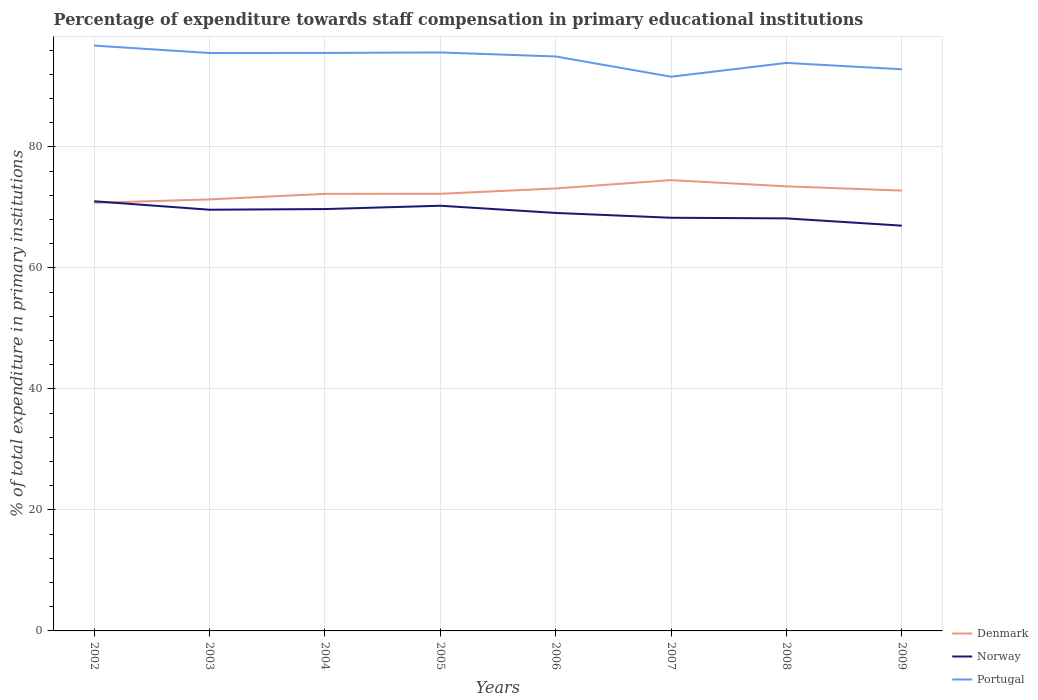How many different coloured lines are there?
Your response must be concise. 3. Does the line corresponding to Denmark intersect with the line corresponding to Norway?
Keep it short and to the point. Yes. Is the number of lines equal to the number of legend labels?
Your answer should be compact. Yes. Across all years, what is the maximum percentage of expenditure towards staff compensation in Norway?
Keep it short and to the point. 66.97. In which year was the percentage of expenditure towards staff compensation in Norway maximum?
Your answer should be very brief. 2009. What is the total percentage of expenditure towards staff compensation in Denmark in the graph?
Offer a terse response. -0.93. What is the difference between the highest and the second highest percentage of expenditure towards staff compensation in Denmark?
Give a very brief answer. 3.75. What is the difference between the highest and the lowest percentage of expenditure towards staff compensation in Portugal?
Your response must be concise. 5. How many years are there in the graph?
Offer a very short reply. 8. What is the difference between two consecutive major ticks on the Y-axis?
Your answer should be compact. 20. Does the graph contain grids?
Your answer should be compact. Yes. Where does the legend appear in the graph?
Provide a succinct answer. Bottom right. How many legend labels are there?
Offer a very short reply. 3. How are the legend labels stacked?
Offer a terse response. Vertical. What is the title of the graph?
Your answer should be compact. Percentage of expenditure towards staff compensation in primary educational institutions. Does "El Salvador" appear as one of the legend labels in the graph?
Offer a terse response. No. What is the label or title of the X-axis?
Your answer should be compact. Years. What is the label or title of the Y-axis?
Make the answer very short. % of total expenditure in primary institutions. What is the % of total expenditure in primary institutions of Denmark in 2002?
Ensure brevity in your answer.  70.75. What is the % of total expenditure in primary institutions of Norway in 2002?
Make the answer very short. 71.01. What is the % of total expenditure in primary institutions in Portugal in 2002?
Your response must be concise. 96.73. What is the % of total expenditure in primary institutions in Denmark in 2003?
Your answer should be compact. 71.31. What is the % of total expenditure in primary institutions of Norway in 2003?
Your response must be concise. 69.61. What is the % of total expenditure in primary institutions of Portugal in 2003?
Keep it short and to the point. 95.51. What is the % of total expenditure in primary institutions of Denmark in 2004?
Give a very brief answer. 72.23. What is the % of total expenditure in primary institutions in Norway in 2004?
Make the answer very short. 69.71. What is the % of total expenditure in primary institutions in Portugal in 2004?
Offer a terse response. 95.52. What is the % of total expenditure in primary institutions in Denmark in 2005?
Make the answer very short. 72.24. What is the % of total expenditure in primary institutions of Norway in 2005?
Provide a short and direct response. 70.27. What is the % of total expenditure in primary institutions in Portugal in 2005?
Make the answer very short. 95.6. What is the % of total expenditure in primary institutions in Denmark in 2006?
Ensure brevity in your answer.  73.12. What is the % of total expenditure in primary institutions in Norway in 2006?
Keep it short and to the point. 69.07. What is the % of total expenditure in primary institutions of Portugal in 2006?
Your answer should be compact. 94.93. What is the % of total expenditure in primary institutions in Denmark in 2007?
Give a very brief answer. 74.5. What is the % of total expenditure in primary institutions of Norway in 2007?
Make the answer very short. 68.28. What is the % of total expenditure in primary institutions of Portugal in 2007?
Your answer should be very brief. 91.59. What is the % of total expenditure in primary institutions in Denmark in 2008?
Your answer should be very brief. 73.47. What is the % of total expenditure in primary institutions of Norway in 2008?
Ensure brevity in your answer.  68.17. What is the % of total expenditure in primary institutions in Portugal in 2008?
Your answer should be compact. 93.87. What is the % of total expenditure in primary institutions of Denmark in 2009?
Your answer should be very brief. 72.77. What is the % of total expenditure in primary institutions of Norway in 2009?
Your response must be concise. 66.97. What is the % of total expenditure in primary institutions in Portugal in 2009?
Your response must be concise. 92.82. Across all years, what is the maximum % of total expenditure in primary institutions of Denmark?
Your answer should be very brief. 74.5. Across all years, what is the maximum % of total expenditure in primary institutions in Norway?
Your answer should be very brief. 71.01. Across all years, what is the maximum % of total expenditure in primary institutions in Portugal?
Make the answer very short. 96.73. Across all years, what is the minimum % of total expenditure in primary institutions of Denmark?
Your answer should be very brief. 70.75. Across all years, what is the minimum % of total expenditure in primary institutions in Norway?
Make the answer very short. 66.97. Across all years, what is the minimum % of total expenditure in primary institutions in Portugal?
Keep it short and to the point. 91.59. What is the total % of total expenditure in primary institutions of Denmark in the graph?
Ensure brevity in your answer.  580.38. What is the total % of total expenditure in primary institutions of Norway in the graph?
Your answer should be compact. 553.09. What is the total % of total expenditure in primary institutions of Portugal in the graph?
Ensure brevity in your answer.  756.56. What is the difference between the % of total expenditure in primary institutions of Denmark in 2002 and that in 2003?
Your response must be concise. -0.56. What is the difference between the % of total expenditure in primary institutions of Norway in 2002 and that in 2003?
Offer a very short reply. 1.4. What is the difference between the % of total expenditure in primary institutions in Portugal in 2002 and that in 2003?
Give a very brief answer. 1.23. What is the difference between the % of total expenditure in primary institutions of Denmark in 2002 and that in 2004?
Provide a succinct answer. -1.48. What is the difference between the % of total expenditure in primary institutions in Norway in 2002 and that in 2004?
Make the answer very short. 1.29. What is the difference between the % of total expenditure in primary institutions in Portugal in 2002 and that in 2004?
Offer a terse response. 1.21. What is the difference between the % of total expenditure in primary institutions of Denmark in 2002 and that in 2005?
Offer a terse response. -1.49. What is the difference between the % of total expenditure in primary institutions in Norway in 2002 and that in 2005?
Make the answer very short. 0.74. What is the difference between the % of total expenditure in primary institutions of Portugal in 2002 and that in 2005?
Your answer should be compact. 1.14. What is the difference between the % of total expenditure in primary institutions of Denmark in 2002 and that in 2006?
Your answer should be compact. -2.38. What is the difference between the % of total expenditure in primary institutions of Norway in 2002 and that in 2006?
Offer a terse response. 1.93. What is the difference between the % of total expenditure in primary institutions of Portugal in 2002 and that in 2006?
Give a very brief answer. 1.8. What is the difference between the % of total expenditure in primary institutions of Denmark in 2002 and that in 2007?
Provide a short and direct response. -3.75. What is the difference between the % of total expenditure in primary institutions in Norway in 2002 and that in 2007?
Make the answer very short. 2.73. What is the difference between the % of total expenditure in primary institutions in Portugal in 2002 and that in 2007?
Give a very brief answer. 5.14. What is the difference between the % of total expenditure in primary institutions in Denmark in 2002 and that in 2008?
Ensure brevity in your answer.  -2.72. What is the difference between the % of total expenditure in primary institutions of Norway in 2002 and that in 2008?
Give a very brief answer. 2.83. What is the difference between the % of total expenditure in primary institutions of Portugal in 2002 and that in 2008?
Your response must be concise. 2.86. What is the difference between the % of total expenditure in primary institutions in Denmark in 2002 and that in 2009?
Your response must be concise. -2.02. What is the difference between the % of total expenditure in primary institutions of Norway in 2002 and that in 2009?
Ensure brevity in your answer.  4.03. What is the difference between the % of total expenditure in primary institutions of Portugal in 2002 and that in 2009?
Ensure brevity in your answer.  3.92. What is the difference between the % of total expenditure in primary institutions in Denmark in 2003 and that in 2004?
Your answer should be compact. -0.92. What is the difference between the % of total expenditure in primary institutions of Norway in 2003 and that in 2004?
Keep it short and to the point. -0.11. What is the difference between the % of total expenditure in primary institutions in Portugal in 2003 and that in 2004?
Your answer should be compact. -0.01. What is the difference between the % of total expenditure in primary institutions of Denmark in 2003 and that in 2005?
Your response must be concise. -0.93. What is the difference between the % of total expenditure in primary institutions in Norway in 2003 and that in 2005?
Your response must be concise. -0.66. What is the difference between the % of total expenditure in primary institutions of Portugal in 2003 and that in 2005?
Make the answer very short. -0.09. What is the difference between the % of total expenditure in primary institutions in Denmark in 2003 and that in 2006?
Offer a very short reply. -1.81. What is the difference between the % of total expenditure in primary institutions of Norway in 2003 and that in 2006?
Ensure brevity in your answer.  0.53. What is the difference between the % of total expenditure in primary institutions of Portugal in 2003 and that in 2006?
Give a very brief answer. 0.57. What is the difference between the % of total expenditure in primary institutions in Denmark in 2003 and that in 2007?
Give a very brief answer. -3.19. What is the difference between the % of total expenditure in primary institutions of Norway in 2003 and that in 2007?
Your answer should be very brief. 1.33. What is the difference between the % of total expenditure in primary institutions of Portugal in 2003 and that in 2007?
Your answer should be compact. 3.92. What is the difference between the % of total expenditure in primary institutions in Denmark in 2003 and that in 2008?
Offer a very short reply. -2.16. What is the difference between the % of total expenditure in primary institutions in Norway in 2003 and that in 2008?
Your answer should be compact. 1.43. What is the difference between the % of total expenditure in primary institutions of Portugal in 2003 and that in 2008?
Your answer should be compact. 1.64. What is the difference between the % of total expenditure in primary institutions of Denmark in 2003 and that in 2009?
Offer a terse response. -1.46. What is the difference between the % of total expenditure in primary institutions in Norway in 2003 and that in 2009?
Offer a terse response. 2.63. What is the difference between the % of total expenditure in primary institutions in Portugal in 2003 and that in 2009?
Offer a very short reply. 2.69. What is the difference between the % of total expenditure in primary institutions of Denmark in 2004 and that in 2005?
Give a very brief answer. -0.01. What is the difference between the % of total expenditure in primary institutions of Norway in 2004 and that in 2005?
Give a very brief answer. -0.55. What is the difference between the % of total expenditure in primary institutions in Portugal in 2004 and that in 2005?
Offer a very short reply. -0.08. What is the difference between the % of total expenditure in primary institutions in Denmark in 2004 and that in 2006?
Ensure brevity in your answer.  -0.89. What is the difference between the % of total expenditure in primary institutions of Norway in 2004 and that in 2006?
Give a very brief answer. 0.64. What is the difference between the % of total expenditure in primary institutions in Portugal in 2004 and that in 2006?
Your answer should be compact. 0.58. What is the difference between the % of total expenditure in primary institutions in Denmark in 2004 and that in 2007?
Ensure brevity in your answer.  -2.27. What is the difference between the % of total expenditure in primary institutions in Norway in 2004 and that in 2007?
Provide a short and direct response. 1.44. What is the difference between the % of total expenditure in primary institutions of Portugal in 2004 and that in 2007?
Ensure brevity in your answer.  3.93. What is the difference between the % of total expenditure in primary institutions in Denmark in 2004 and that in 2008?
Offer a very short reply. -1.24. What is the difference between the % of total expenditure in primary institutions of Norway in 2004 and that in 2008?
Your response must be concise. 1.54. What is the difference between the % of total expenditure in primary institutions in Portugal in 2004 and that in 2008?
Your answer should be very brief. 1.65. What is the difference between the % of total expenditure in primary institutions of Denmark in 2004 and that in 2009?
Provide a short and direct response. -0.54. What is the difference between the % of total expenditure in primary institutions in Norway in 2004 and that in 2009?
Offer a terse response. 2.74. What is the difference between the % of total expenditure in primary institutions in Portugal in 2004 and that in 2009?
Give a very brief answer. 2.7. What is the difference between the % of total expenditure in primary institutions in Denmark in 2005 and that in 2006?
Provide a short and direct response. -0.88. What is the difference between the % of total expenditure in primary institutions of Norway in 2005 and that in 2006?
Keep it short and to the point. 1.19. What is the difference between the % of total expenditure in primary institutions in Portugal in 2005 and that in 2006?
Offer a very short reply. 0.66. What is the difference between the % of total expenditure in primary institutions in Denmark in 2005 and that in 2007?
Your answer should be very brief. -2.26. What is the difference between the % of total expenditure in primary institutions of Norway in 2005 and that in 2007?
Keep it short and to the point. 1.99. What is the difference between the % of total expenditure in primary institutions in Portugal in 2005 and that in 2007?
Offer a very short reply. 4.01. What is the difference between the % of total expenditure in primary institutions of Denmark in 2005 and that in 2008?
Provide a succinct answer. -1.23. What is the difference between the % of total expenditure in primary institutions of Norway in 2005 and that in 2008?
Keep it short and to the point. 2.09. What is the difference between the % of total expenditure in primary institutions of Portugal in 2005 and that in 2008?
Provide a succinct answer. 1.73. What is the difference between the % of total expenditure in primary institutions of Denmark in 2005 and that in 2009?
Offer a terse response. -0.53. What is the difference between the % of total expenditure in primary institutions of Norway in 2005 and that in 2009?
Make the answer very short. 3.29. What is the difference between the % of total expenditure in primary institutions in Portugal in 2005 and that in 2009?
Offer a terse response. 2.78. What is the difference between the % of total expenditure in primary institutions of Denmark in 2006 and that in 2007?
Keep it short and to the point. -1.37. What is the difference between the % of total expenditure in primary institutions in Norway in 2006 and that in 2007?
Give a very brief answer. 0.8. What is the difference between the % of total expenditure in primary institutions in Portugal in 2006 and that in 2007?
Ensure brevity in your answer.  3.35. What is the difference between the % of total expenditure in primary institutions in Denmark in 2006 and that in 2008?
Your answer should be very brief. -0.35. What is the difference between the % of total expenditure in primary institutions of Norway in 2006 and that in 2008?
Make the answer very short. 0.9. What is the difference between the % of total expenditure in primary institutions of Portugal in 2006 and that in 2008?
Make the answer very short. 1.06. What is the difference between the % of total expenditure in primary institutions of Denmark in 2006 and that in 2009?
Keep it short and to the point. 0.36. What is the difference between the % of total expenditure in primary institutions in Norway in 2006 and that in 2009?
Provide a succinct answer. 2.1. What is the difference between the % of total expenditure in primary institutions of Portugal in 2006 and that in 2009?
Your response must be concise. 2.12. What is the difference between the % of total expenditure in primary institutions in Denmark in 2007 and that in 2008?
Your answer should be compact. 1.03. What is the difference between the % of total expenditure in primary institutions in Norway in 2007 and that in 2008?
Make the answer very short. 0.11. What is the difference between the % of total expenditure in primary institutions in Portugal in 2007 and that in 2008?
Your response must be concise. -2.28. What is the difference between the % of total expenditure in primary institutions in Denmark in 2007 and that in 2009?
Your response must be concise. 1.73. What is the difference between the % of total expenditure in primary institutions in Norway in 2007 and that in 2009?
Offer a terse response. 1.3. What is the difference between the % of total expenditure in primary institutions of Portugal in 2007 and that in 2009?
Offer a terse response. -1.23. What is the difference between the % of total expenditure in primary institutions of Denmark in 2008 and that in 2009?
Ensure brevity in your answer.  0.7. What is the difference between the % of total expenditure in primary institutions in Portugal in 2008 and that in 2009?
Offer a terse response. 1.05. What is the difference between the % of total expenditure in primary institutions in Denmark in 2002 and the % of total expenditure in primary institutions in Norway in 2003?
Offer a very short reply. 1.14. What is the difference between the % of total expenditure in primary institutions of Denmark in 2002 and the % of total expenditure in primary institutions of Portugal in 2003?
Provide a succinct answer. -24.76. What is the difference between the % of total expenditure in primary institutions in Norway in 2002 and the % of total expenditure in primary institutions in Portugal in 2003?
Provide a short and direct response. -24.5. What is the difference between the % of total expenditure in primary institutions of Denmark in 2002 and the % of total expenditure in primary institutions of Norway in 2004?
Your answer should be very brief. 1.03. What is the difference between the % of total expenditure in primary institutions of Denmark in 2002 and the % of total expenditure in primary institutions of Portugal in 2004?
Your answer should be very brief. -24.77. What is the difference between the % of total expenditure in primary institutions in Norway in 2002 and the % of total expenditure in primary institutions in Portugal in 2004?
Your answer should be very brief. -24.51. What is the difference between the % of total expenditure in primary institutions in Denmark in 2002 and the % of total expenditure in primary institutions in Norway in 2005?
Keep it short and to the point. 0.48. What is the difference between the % of total expenditure in primary institutions of Denmark in 2002 and the % of total expenditure in primary institutions of Portugal in 2005?
Your response must be concise. -24.85. What is the difference between the % of total expenditure in primary institutions of Norway in 2002 and the % of total expenditure in primary institutions of Portugal in 2005?
Provide a short and direct response. -24.59. What is the difference between the % of total expenditure in primary institutions of Denmark in 2002 and the % of total expenditure in primary institutions of Norway in 2006?
Give a very brief answer. 1.67. What is the difference between the % of total expenditure in primary institutions of Denmark in 2002 and the % of total expenditure in primary institutions of Portugal in 2006?
Your response must be concise. -24.19. What is the difference between the % of total expenditure in primary institutions in Norway in 2002 and the % of total expenditure in primary institutions in Portugal in 2006?
Your response must be concise. -23.93. What is the difference between the % of total expenditure in primary institutions in Denmark in 2002 and the % of total expenditure in primary institutions in Norway in 2007?
Provide a succinct answer. 2.47. What is the difference between the % of total expenditure in primary institutions in Denmark in 2002 and the % of total expenditure in primary institutions in Portugal in 2007?
Make the answer very short. -20.84. What is the difference between the % of total expenditure in primary institutions in Norway in 2002 and the % of total expenditure in primary institutions in Portugal in 2007?
Offer a terse response. -20.58. What is the difference between the % of total expenditure in primary institutions in Denmark in 2002 and the % of total expenditure in primary institutions in Norway in 2008?
Offer a terse response. 2.57. What is the difference between the % of total expenditure in primary institutions of Denmark in 2002 and the % of total expenditure in primary institutions of Portugal in 2008?
Ensure brevity in your answer.  -23.12. What is the difference between the % of total expenditure in primary institutions of Norway in 2002 and the % of total expenditure in primary institutions of Portugal in 2008?
Your answer should be very brief. -22.86. What is the difference between the % of total expenditure in primary institutions in Denmark in 2002 and the % of total expenditure in primary institutions in Norway in 2009?
Give a very brief answer. 3.77. What is the difference between the % of total expenditure in primary institutions in Denmark in 2002 and the % of total expenditure in primary institutions in Portugal in 2009?
Offer a terse response. -22.07. What is the difference between the % of total expenditure in primary institutions in Norway in 2002 and the % of total expenditure in primary institutions in Portugal in 2009?
Make the answer very short. -21.81. What is the difference between the % of total expenditure in primary institutions of Denmark in 2003 and the % of total expenditure in primary institutions of Norway in 2004?
Give a very brief answer. 1.6. What is the difference between the % of total expenditure in primary institutions in Denmark in 2003 and the % of total expenditure in primary institutions in Portugal in 2004?
Make the answer very short. -24.21. What is the difference between the % of total expenditure in primary institutions in Norway in 2003 and the % of total expenditure in primary institutions in Portugal in 2004?
Your answer should be compact. -25.91. What is the difference between the % of total expenditure in primary institutions in Denmark in 2003 and the % of total expenditure in primary institutions in Norway in 2005?
Offer a terse response. 1.04. What is the difference between the % of total expenditure in primary institutions in Denmark in 2003 and the % of total expenditure in primary institutions in Portugal in 2005?
Provide a short and direct response. -24.29. What is the difference between the % of total expenditure in primary institutions of Norway in 2003 and the % of total expenditure in primary institutions of Portugal in 2005?
Your response must be concise. -25.99. What is the difference between the % of total expenditure in primary institutions in Denmark in 2003 and the % of total expenditure in primary institutions in Norway in 2006?
Give a very brief answer. 2.24. What is the difference between the % of total expenditure in primary institutions in Denmark in 2003 and the % of total expenditure in primary institutions in Portugal in 2006?
Your response must be concise. -23.62. What is the difference between the % of total expenditure in primary institutions of Norway in 2003 and the % of total expenditure in primary institutions of Portugal in 2006?
Your answer should be compact. -25.33. What is the difference between the % of total expenditure in primary institutions of Denmark in 2003 and the % of total expenditure in primary institutions of Norway in 2007?
Your answer should be very brief. 3.03. What is the difference between the % of total expenditure in primary institutions of Denmark in 2003 and the % of total expenditure in primary institutions of Portugal in 2007?
Your response must be concise. -20.28. What is the difference between the % of total expenditure in primary institutions of Norway in 2003 and the % of total expenditure in primary institutions of Portugal in 2007?
Ensure brevity in your answer.  -21.98. What is the difference between the % of total expenditure in primary institutions of Denmark in 2003 and the % of total expenditure in primary institutions of Norway in 2008?
Give a very brief answer. 3.14. What is the difference between the % of total expenditure in primary institutions in Denmark in 2003 and the % of total expenditure in primary institutions in Portugal in 2008?
Make the answer very short. -22.56. What is the difference between the % of total expenditure in primary institutions of Norway in 2003 and the % of total expenditure in primary institutions of Portugal in 2008?
Keep it short and to the point. -24.26. What is the difference between the % of total expenditure in primary institutions of Denmark in 2003 and the % of total expenditure in primary institutions of Norway in 2009?
Provide a succinct answer. 4.34. What is the difference between the % of total expenditure in primary institutions of Denmark in 2003 and the % of total expenditure in primary institutions of Portugal in 2009?
Keep it short and to the point. -21.51. What is the difference between the % of total expenditure in primary institutions of Norway in 2003 and the % of total expenditure in primary institutions of Portugal in 2009?
Your answer should be very brief. -23.21. What is the difference between the % of total expenditure in primary institutions of Denmark in 2004 and the % of total expenditure in primary institutions of Norway in 2005?
Provide a short and direct response. 1.96. What is the difference between the % of total expenditure in primary institutions of Denmark in 2004 and the % of total expenditure in primary institutions of Portugal in 2005?
Your answer should be very brief. -23.37. What is the difference between the % of total expenditure in primary institutions of Norway in 2004 and the % of total expenditure in primary institutions of Portugal in 2005?
Offer a terse response. -25.88. What is the difference between the % of total expenditure in primary institutions of Denmark in 2004 and the % of total expenditure in primary institutions of Norway in 2006?
Give a very brief answer. 3.15. What is the difference between the % of total expenditure in primary institutions of Denmark in 2004 and the % of total expenditure in primary institutions of Portugal in 2006?
Keep it short and to the point. -22.71. What is the difference between the % of total expenditure in primary institutions of Norway in 2004 and the % of total expenditure in primary institutions of Portugal in 2006?
Offer a very short reply. -25.22. What is the difference between the % of total expenditure in primary institutions in Denmark in 2004 and the % of total expenditure in primary institutions in Norway in 2007?
Your answer should be very brief. 3.95. What is the difference between the % of total expenditure in primary institutions of Denmark in 2004 and the % of total expenditure in primary institutions of Portugal in 2007?
Your answer should be very brief. -19.36. What is the difference between the % of total expenditure in primary institutions in Norway in 2004 and the % of total expenditure in primary institutions in Portugal in 2007?
Give a very brief answer. -21.87. What is the difference between the % of total expenditure in primary institutions in Denmark in 2004 and the % of total expenditure in primary institutions in Norway in 2008?
Your answer should be compact. 4.05. What is the difference between the % of total expenditure in primary institutions in Denmark in 2004 and the % of total expenditure in primary institutions in Portugal in 2008?
Offer a very short reply. -21.64. What is the difference between the % of total expenditure in primary institutions in Norway in 2004 and the % of total expenditure in primary institutions in Portugal in 2008?
Your answer should be very brief. -24.15. What is the difference between the % of total expenditure in primary institutions in Denmark in 2004 and the % of total expenditure in primary institutions in Norway in 2009?
Provide a succinct answer. 5.25. What is the difference between the % of total expenditure in primary institutions of Denmark in 2004 and the % of total expenditure in primary institutions of Portugal in 2009?
Give a very brief answer. -20.59. What is the difference between the % of total expenditure in primary institutions in Norway in 2004 and the % of total expenditure in primary institutions in Portugal in 2009?
Ensure brevity in your answer.  -23.1. What is the difference between the % of total expenditure in primary institutions in Denmark in 2005 and the % of total expenditure in primary institutions in Norway in 2006?
Ensure brevity in your answer.  3.16. What is the difference between the % of total expenditure in primary institutions in Denmark in 2005 and the % of total expenditure in primary institutions in Portugal in 2006?
Provide a short and direct response. -22.69. What is the difference between the % of total expenditure in primary institutions in Norway in 2005 and the % of total expenditure in primary institutions in Portugal in 2006?
Give a very brief answer. -24.67. What is the difference between the % of total expenditure in primary institutions in Denmark in 2005 and the % of total expenditure in primary institutions in Norway in 2007?
Your answer should be compact. 3.96. What is the difference between the % of total expenditure in primary institutions of Denmark in 2005 and the % of total expenditure in primary institutions of Portugal in 2007?
Keep it short and to the point. -19.35. What is the difference between the % of total expenditure in primary institutions in Norway in 2005 and the % of total expenditure in primary institutions in Portugal in 2007?
Ensure brevity in your answer.  -21.32. What is the difference between the % of total expenditure in primary institutions in Denmark in 2005 and the % of total expenditure in primary institutions in Norway in 2008?
Provide a succinct answer. 4.06. What is the difference between the % of total expenditure in primary institutions of Denmark in 2005 and the % of total expenditure in primary institutions of Portugal in 2008?
Your answer should be compact. -21.63. What is the difference between the % of total expenditure in primary institutions in Norway in 2005 and the % of total expenditure in primary institutions in Portugal in 2008?
Keep it short and to the point. -23.6. What is the difference between the % of total expenditure in primary institutions in Denmark in 2005 and the % of total expenditure in primary institutions in Norway in 2009?
Keep it short and to the point. 5.26. What is the difference between the % of total expenditure in primary institutions in Denmark in 2005 and the % of total expenditure in primary institutions in Portugal in 2009?
Offer a terse response. -20.58. What is the difference between the % of total expenditure in primary institutions in Norway in 2005 and the % of total expenditure in primary institutions in Portugal in 2009?
Give a very brief answer. -22.55. What is the difference between the % of total expenditure in primary institutions in Denmark in 2006 and the % of total expenditure in primary institutions in Norway in 2007?
Provide a succinct answer. 4.84. What is the difference between the % of total expenditure in primary institutions of Denmark in 2006 and the % of total expenditure in primary institutions of Portugal in 2007?
Provide a short and direct response. -18.46. What is the difference between the % of total expenditure in primary institutions in Norway in 2006 and the % of total expenditure in primary institutions in Portugal in 2007?
Give a very brief answer. -22.51. What is the difference between the % of total expenditure in primary institutions in Denmark in 2006 and the % of total expenditure in primary institutions in Norway in 2008?
Offer a terse response. 4.95. What is the difference between the % of total expenditure in primary institutions in Denmark in 2006 and the % of total expenditure in primary institutions in Portugal in 2008?
Provide a succinct answer. -20.75. What is the difference between the % of total expenditure in primary institutions in Norway in 2006 and the % of total expenditure in primary institutions in Portugal in 2008?
Your response must be concise. -24.79. What is the difference between the % of total expenditure in primary institutions of Denmark in 2006 and the % of total expenditure in primary institutions of Norway in 2009?
Your response must be concise. 6.15. What is the difference between the % of total expenditure in primary institutions in Denmark in 2006 and the % of total expenditure in primary institutions in Portugal in 2009?
Ensure brevity in your answer.  -19.69. What is the difference between the % of total expenditure in primary institutions in Norway in 2006 and the % of total expenditure in primary institutions in Portugal in 2009?
Your answer should be compact. -23.74. What is the difference between the % of total expenditure in primary institutions in Denmark in 2007 and the % of total expenditure in primary institutions in Norway in 2008?
Keep it short and to the point. 6.32. What is the difference between the % of total expenditure in primary institutions of Denmark in 2007 and the % of total expenditure in primary institutions of Portugal in 2008?
Keep it short and to the point. -19.37. What is the difference between the % of total expenditure in primary institutions of Norway in 2007 and the % of total expenditure in primary institutions of Portugal in 2008?
Provide a short and direct response. -25.59. What is the difference between the % of total expenditure in primary institutions of Denmark in 2007 and the % of total expenditure in primary institutions of Norway in 2009?
Provide a short and direct response. 7.52. What is the difference between the % of total expenditure in primary institutions of Denmark in 2007 and the % of total expenditure in primary institutions of Portugal in 2009?
Your answer should be very brief. -18.32. What is the difference between the % of total expenditure in primary institutions of Norway in 2007 and the % of total expenditure in primary institutions of Portugal in 2009?
Keep it short and to the point. -24.54. What is the difference between the % of total expenditure in primary institutions in Denmark in 2008 and the % of total expenditure in primary institutions in Norway in 2009?
Make the answer very short. 6.5. What is the difference between the % of total expenditure in primary institutions of Denmark in 2008 and the % of total expenditure in primary institutions of Portugal in 2009?
Offer a terse response. -19.35. What is the difference between the % of total expenditure in primary institutions of Norway in 2008 and the % of total expenditure in primary institutions of Portugal in 2009?
Offer a very short reply. -24.64. What is the average % of total expenditure in primary institutions of Denmark per year?
Your answer should be very brief. 72.55. What is the average % of total expenditure in primary institutions of Norway per year?
Offer a very short reply. 69.14. What is the average % of total expenditure in primary institutions of Portugal per year?
Your response must be concise. 94.57. In the year 2002, what is the difference between the % of total expenditure in primary institutions in Denmark and % of total expenditure in primary institutions in Norway?
Keep it short and to the point. -0.26. In the year 2002, what is the difference between the % of total expenditure in primary institutions in Denmark and % of total expenditure in primary institutions in Portugal?
Make the answer very short. -25.99. In the year 2002, what is the difference between the % of total expenditure in primary institutions in Norway and % of total expenditure in primary institutions in Portugal?
Make the answer very short. -25.73. In the year 2003, what is the difference between the % of total expenditure in primary institutions of Denmark and % of total expenditure in primary institutions of Norway?
Ensure brevity in your answer.  1.7. In the year 2003, what is the difference between the % of total expenditure in primary institutions of Denmark and % of total expenditure in primary institutions of Portugal?
Your response must be concise. -24.2. In the year 2003, what is the difference between the % of total expenditure in primary institutions of Norway and % of total expenditure in primary institutions of Portugal?
Your response must be concise. -25.9. In the year 2004, what is the difference between the % of total expenditure in primary institutions of Denmark and % of total expenditure in primary institutions of Norway?
Ensure brevity in your answer.  2.51. In the year 2004, what is the difference between the % of total expenditure in primary institutions of Denmark and % of total expenditure in primary institutions of Portugal?
Your response must be concise. -23.29. In the year 2004, what is the difference between the % of total expenditure in primary institutions of Norway and % of total expenditure in primary institutions of Portugal?
Give a very brief answer. -25.8. In the year 2005, what is the difference between the % of total expenditure in primary institutions in Denmark and % of total expenditure in primary institutions in Norway?
Offer a very short reply. 1.97. In the year 2005, what is the difference between the % of total expenditure in primary institutions of Denmark and % of total expenditure in primary institutions of Portugal?
Your answer should be compact. -23.36. In the year 2005, what is the difference between the % of total expenditure in primary institutions of Norway and % of total expenditure in primary institutions of Portugal?
Offer a terse response. -25.33. In the year 2006, what is the difference between the % of total expenditure in primary institutions in Denmark and % of total expenditure in primary institutions in Norway?
Keep it short and to the point. 4.05. In the year 2006, what is the difference between the % of total expenditure in primary institutions of Denmark and % of total expenditure in primary institutions of Portugal?
Provide a succinct answer. -21.81. In the year 2006, what is the difference between the % of total expenditure in primary institutions in Norway and % of total expenditure in primary institutions in Portugal?
Offer a very short reply. -25.86. In the year 2007, what is the difference between the % of total expenditure in primary institutions of Denmark and % of total expenditure in primary institutions of Norway?
Provide a succinct answer. 6.22. In the year 2007, what is the difference between the % of total expenditure in primary institutions of Denmark and % of total expenditure in primary institutions of Portugal?
Ensure brevity in your answer.  -17.09. In the year 2007, what is the difference between the % of total expenditure in primary institutions of Norway and % of total expenditure in primary institutions of Portugal?
Provide a succinct answer. -23.31. In the year 2008, what is the difference between the % of total expenditure in primary institutions in Denmark and % of total expenditure in primary institutions in Norway?
Provide a short and direct response. 5.3. In the year 2008, what is the difference between the % of total expenditure in primary institutions in Denmark and % of total expenditure in primary institutions in Portugal?
Your response must be concise. -20.4. In the year 2008, what is the difference between the % of total expenditure in primary institutions of Norway and % of total expenditure in primary institutions of Portugal?
Your answer should be compact. -25.69. In the year 2009, what is the difference between the % of total expenditure in primary institutions in Denmark and % of total expenditure in primary institutions in Norway?
Ensure brevity in your answer.  5.79. In the year 2009, what is the difference between the % of total expenditure in primary institutions of Denmark and % of total expenditure in primary institutions of Portugal?
Your answer should be very brief. -20.05. In the year 2009, what is the difference between the % of total expenditure in primary institutions in Norway and % of total expenditure in primary institutions in Portugal?
Ensure brevity in your answer.  -25.84. What is the ratio of the % of total expenditure in primary institutions in Denmark in 2002 to that in 2003?
Provide a short and direct response. 0.99. What is the ratio of the % of total expenditure in primary institutions of Norway in 2002 to that in 2003?
Give a very brief answer. 1.02. What is the ratio of the % of total expenditure in primary institutions of Portugal in 2002 to that in 2003?
Provide a succinct answer. 1.01. What is the ratio of the % of total expenditure in primary institutions of Denmark in 2002 to that in 2004?
Your answer should be compact. 0.98. What is the ratio of the % of total expenditure in primary institutions in Norway in 2002 to that in 2004?
Your answer should be very brief. 1.02. What is the ratio of the % of total expenditure in primary institutions of Portugal in 2002 to that in 2004?
Keep it short and to the point. 1.01. What is the ratio of the % of total expenditure in primary institutions of Denmark in 2002 to that in 2005?
Provide a short and direct response. 0.98. What is the ratio of the % of total expenditure in primary institutions of Norway in 2002 to that in 2005?
Offer a terse response. 1.01. What is the ratio of the % of total expenditure in primary institutions of Portugal in 2002 to that in 2005?
Your answer should be compact. 1.01. What is the ratio of the % of total expenditure in primary institutions of Denmark in 2002 to that in 2006?
Make the answer very short. 0.97. What is the ratio of the % of total expenditure in primary institutions in Norway in 2002 to that in 2006?
Provide a short and direct response. 1.03. What is the ratio of the % of total expenditure in primary institutions of Portugal in 2002 to that in 2006?
Ensure brevity in your answer.  1.02. What is the ratio of the % of total expenditure in primary institutions in Denmark in 2002 to that in 2007?
Keep it short and to the point. 0.95. What is the ratio of the % of total expenditure in primary institutions of Norway in 2002 to that in 2007?
Your answer should be compact. 1.04. What is the ratio of the % of total expenditure in primary institutions in Portugal in 2002 to that in 2007?
Provide a succinct answer. 1.06. What is the ratio of the % of total expenditure in primary institutions of Denmark in 2002 to that in 2008?
Offer a terse response. 0.96. What is the ratio of the % of total expenditure in primary institutions of Norway in 2002 to that in 2008?
Provide a short and direct response. 1.04. What is the ratio of the % of total expenditure in primary institutions of Portugal in 2002 to that in 2008?
Ensure brevity in your answer.  1.03. What is the ratio of the % of total expenditure in primary institutions in Denmark in 2002 to that in 2009?
Make the answer very short. 0.97. What is the ratio of the % of total expenditure in primary institutions of Norway in 2002 to that in 2009?
Provide a short and direct response. 1.06. What is the ratio of the % of total expenditure in primary institutions of Portugal in 2002 to that in 2009?
Offer a very short reply. 1.04. What is the ratio of the % of total expenditure in primary institutions in Denmark in 2003 to that in 2004?
Your answer should be compact. 0.99. What is the ratio of the % of total expenditure in primary institutions of Norway in 2003 to that in 2004?
Your answer should be compact. 1. What is the ratio of the % of total expenditure in primary institutions in Portugal in 2003 to that in 2004?
Your answer should be very brief. 1. What is the ratio of the % of total expenditure in primary institutions in Denmark in 2003 to that in 2005?
Offer a very short reply. 0.99. What is the ratio of the % of total expenditure in primary institutions of Norway in 2003 to that in 2005?
Your answer should be very brief. 0.99. What is the ratio of the % of total expenditure in primary institutions of Denmark in 2003 to that in 2006?
Your answer should be very brief. 0.98. What is the ratio of the % of total expenditure in primary institutions in Norway in 2003 to that in 2006?
Provide a short and direct response. 1.01. What is the ratio of the % of total expenditure in primary institutions in Denmark in 2003 to that in 2007?
Your answer should be very brief. 0.96. What is the ratio of the % of total expenditure in primary institutions in Norway in 2003 to that in 2007?
Your answer should be very brief. 1.02. What is the ratio of the % of total expenditure in primary institutions in Portugal in 2003 to that in 2007?
Give a very brief answer. 1.04. What is the ratio of the % of total expenditure in primary institutions in Denmark in 2003 to that in 2008?
Your answer should be very brief. 0.97. What is the ratio of the % of total expenditure in primary institutions in Portugal in 2003 to that in 2008?
Provide a short and direct response. 1.02. What is the ratio of the % of total expenditure in primary institutions of Norway in 2003 to that in 2009?
Your answer should be compact. 1.04. What is the ratio of the % of total expenditure in primary institutions of Portugal in 2003 to that in 2009?
Provide a short and direct response. 1.03. What is the ratio of the % of total expenditure in primary institutions in Norway in 2004 to that in 2005?
Offer a very short reply. 0.99. What is the ratio of the % of total expenditure in primary institutions of Norway in 2004 to that in 2006?
Give a very brief answer. 1.01. What is the ratio of the % of total expenditure in primary institutions of Denmark in 2004 to that in 2007?
Make the answer very short. 0.97. What is the ratio of the % of total expenditure in primary institutions in Portugal in 2004 to that in 2007?
Offer a terse response. 1.04. What is the ratio of the % of total expenditure in primary institutions of Denmark in 2004 to that in 2008?
Give a very brief answer. 0.98. What is the ratio of the % of total expenditure in primary institutions of Norway in 2004 to that in 2008?
Give a very brief answer. 1.02. What is the ratio of the % of total expenditure in primary institutions in Portugal in 2004 to that in 2008?
Ensure brevity in your answer.  1.02. What is the ratio of the % of total expenditure in primary institutions in Denmark in 2004 to that in 2009?
Give a very brief answer. 0.99. What is the ratio of the % of total expenditure in primary institutions in Norway in 2004 to that in 2009?
Your answer should be compact. 1.04. What is the ratio of the % of total expenditure in primary institutions of Portugal in 2004 to that in 2009?
Your answer should be very brief. 1.03. What is the ratio of the % of total expenditure in primary institutions of Denmark in 2005 to that in 2006?
Offer a terse response. 0.99. What is the ratio of the % of total expenditure in primary institutions in Norway in 2005 to that in 2006?
Offer a terse response. 1.02. What is the ratio of the % of total expenditure in primary institutions in Denmark in 2005 to that in 2007?
Your answer should be very brief. 0.97. What is the ratio of the % of total expenditure in primary institutions in Norway in 2005 to that in 2007?
Your answer should be very brief. 1.03. What is the ratio of the % of total expenditure in primary institutions in Portugal in 2005 to that in 2007?
Your answer should be compact. 1.04. What is the ratio of the % of total expenditure in primary institutions in Denmark in 2005 to that in 2008?
Provide a short and direct response. 0.98. What is the ratio of the % of total expenditure in primary institutions of Norway in 2005 to that in 2008?
Provide a succinct answer. 1.03. What is the ratio of the % of total expenditure in primary institutions of Portugal in 2005 to that in 2008?
Make the answer very short. 1.02. What is the ratio of the % of total expenditure in primary institutions of Denmark in 2005 to that in 2009?
Ensure brevity in your answer.  0.99. What is the ratio of the % of total expenditure in primary institutions in Norway in 2005 to that in 2009?
Provide a short and direct response. 1.05. What is the ratio of the % of total expenditure in primary institutions of Portugal in 2005 to that in 2009?
Ensure brevity in your answer.  1.03. What is the ratio of the % of total expenditure in primary institutions of Denmark in 2006 to that in 2007?
Give a very brief answer. 0.98. What is the ratio of the % of total expenditure in primary institutions in Norway in 2006 to that in 2007?
Your answer should be very brief. 1.01. What is the ratio of the % of total expenditure in primary institutions of Portugal in 2006 to that in 2007?
Provide a succinct answer. 1.04. What is the ratio of the % of total expenditure in primary institutions in Denmark in 2006 to that in 2008?
Give a very brief answer. 1. What is the ratio of the % of total expenditure in primary institutions of Norway in 2006 to that in 2008?
Offer a terse response. 1.01. What is the ratio of the % of total expenditure in primary institutions in Portugal in 2006 to that in 2008?
Keep it short and to the point. 1.01. What is the ratio of the % of total expenditure in primary institutions of Denmark in 2006 to that in 2009?
Keep it short and to the point. 1. What is the ratio of the % of total expenditure in primary institutions in Norway in 2006 to that in 2009?
Ensure brevity in your answer.  1.03. What is the ratio of the % of total expenditure in primary institutions of Portugal in 2006 to that in 2009?
Your answer should be very brief. 1.02. What is the ratio of the % of total expenditure in primary institutions of Portugal in 2007 to that in 2008?
Provide a succinct answer. 0.98. What is the ratio of the % of total expenditure in primary institutions of Denmark in 2007 to that in 2009?
Your answer should be very brief. 1.02. What is the ratio of the % of total expenditure in primary institutions in Norway in 2007 to that in 2009?
Your answer should be very brief. 1.02. What is the ratio of the % of total expenditure in primary institutions of Denmark in 2008 to that in 2009?
Your answer should be very brief. 1.01. What is the ratio of the % of total expenditure in primary institutions of Norway in 2008 to that in 2009?
Your answer should be very brief. 1.02. What is the ratio of the % of total expenditure in primary institutions of Portugal in 2008 to that in 2009?
Offer a very short reply. 1.01. What is the difference between the highest and the second highest % of total expenditure in primary institutions in Denmark?
Offer a terse response. 1.03. What is the difference between the highest and the second highest % of total expenditure in primary institutions of Norway?
Offer a very short reply. 0.74. What is the difference between the highest and the second highest % of total expenditure in primary institutions in Portugal?
Keep it short and to the point. 1.14. What is the difference between the highest and the lowest % of total expenditure in primary institutions of Denmark?
Ensure brevity in your answer.  3.75. What is the difference between the highest and the lowest % of total expenditure in primary institutions of Norway?
Provide a short and direct response. 4.03. What is the difference between the highest and the lowest % of total expenditure in primary institutions of Portugal?
Your answer should be very brief. 5.14. 